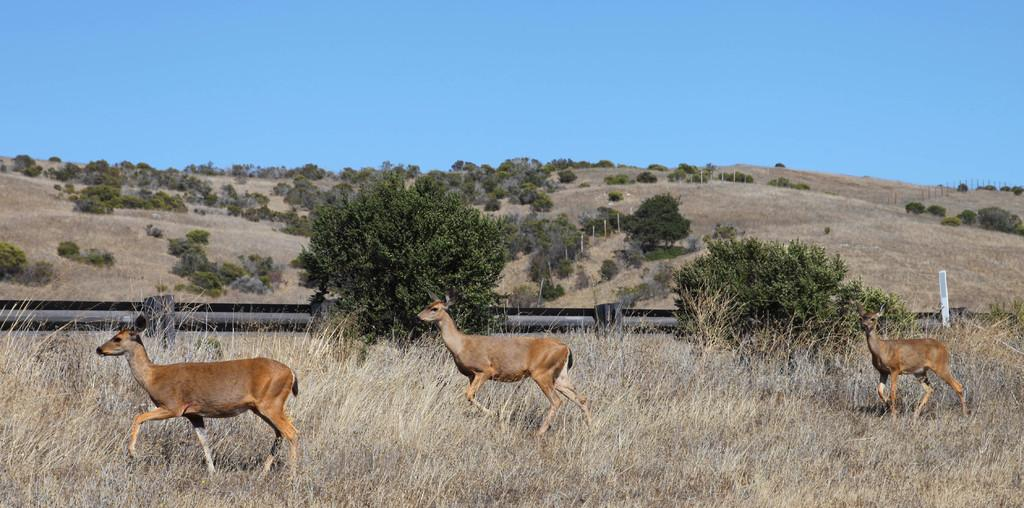What animals can be seen in the image? There are deer walking in the grass. What is visible in the background of the image? There is fencing, trees, poles, hills, and the sky visible in the background. Can you describe the environment in which the deer are located? The deer are walking in the grass, and there are hills and trees in the background. What type of furniture can be seen in the image? There is no furniture present in the image; it features deer walking in the grass with a background of fencing, trees, poles, hills, and the sky. 